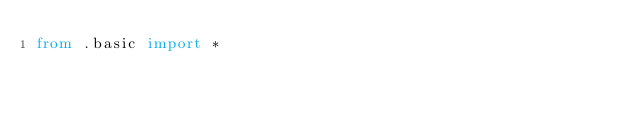<code> <loc_0><loc_0><loc_500><loc_500><_Python_>from .basic import *</code> 